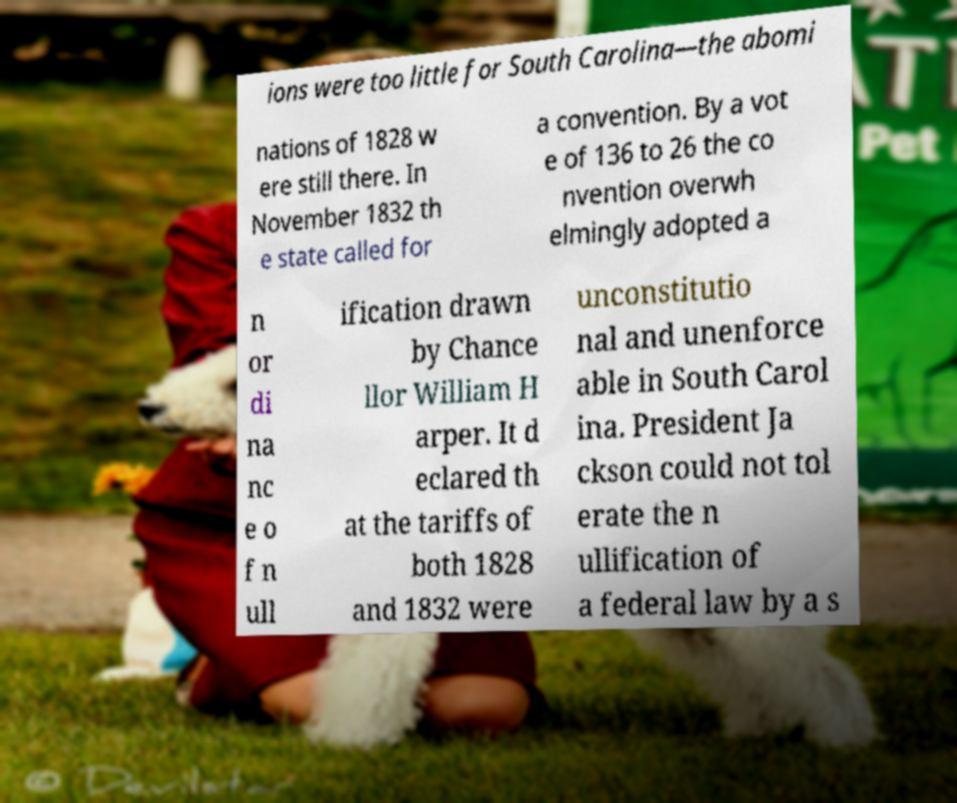For documentation purposes, I need the text within this image transcribed. Could you provide that? ions were too little for South Carolina—the abomi nations of 1828 w ere still there. In November 1832 th e state called for a convention. By a vot e of 136 to 26 the co nvention overwh elmingly adopted a n or di na nc e o f n ull ification drawn by Chance llor William H arper. It d eclared th at the tariffs of both 1828 and 1832 were unconstitutio nal and unenforce able in South Carol ina. President Ja ckson could not tol erate the n ullification of a federal law by a s 